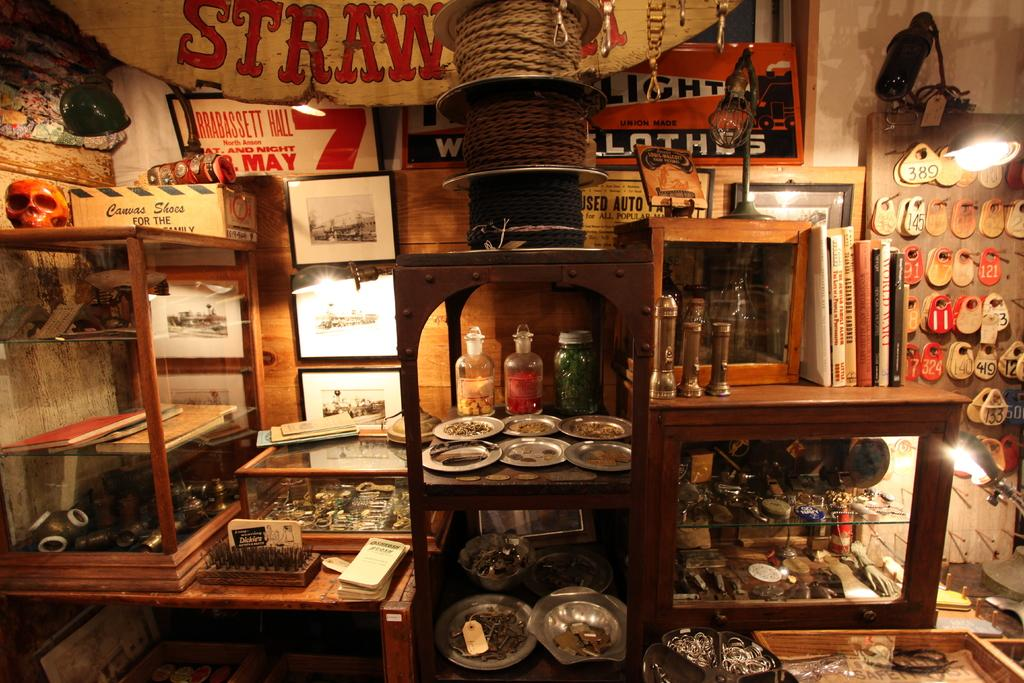What can be seen in the image? There is a shelf in the image. How are the items on the shelf arranged? The items on the shelf are arranged in rows. How many trucks are parked on the shelf in the image? There are no trucks present in the image; it only features a shelf with items arranged in rows. 